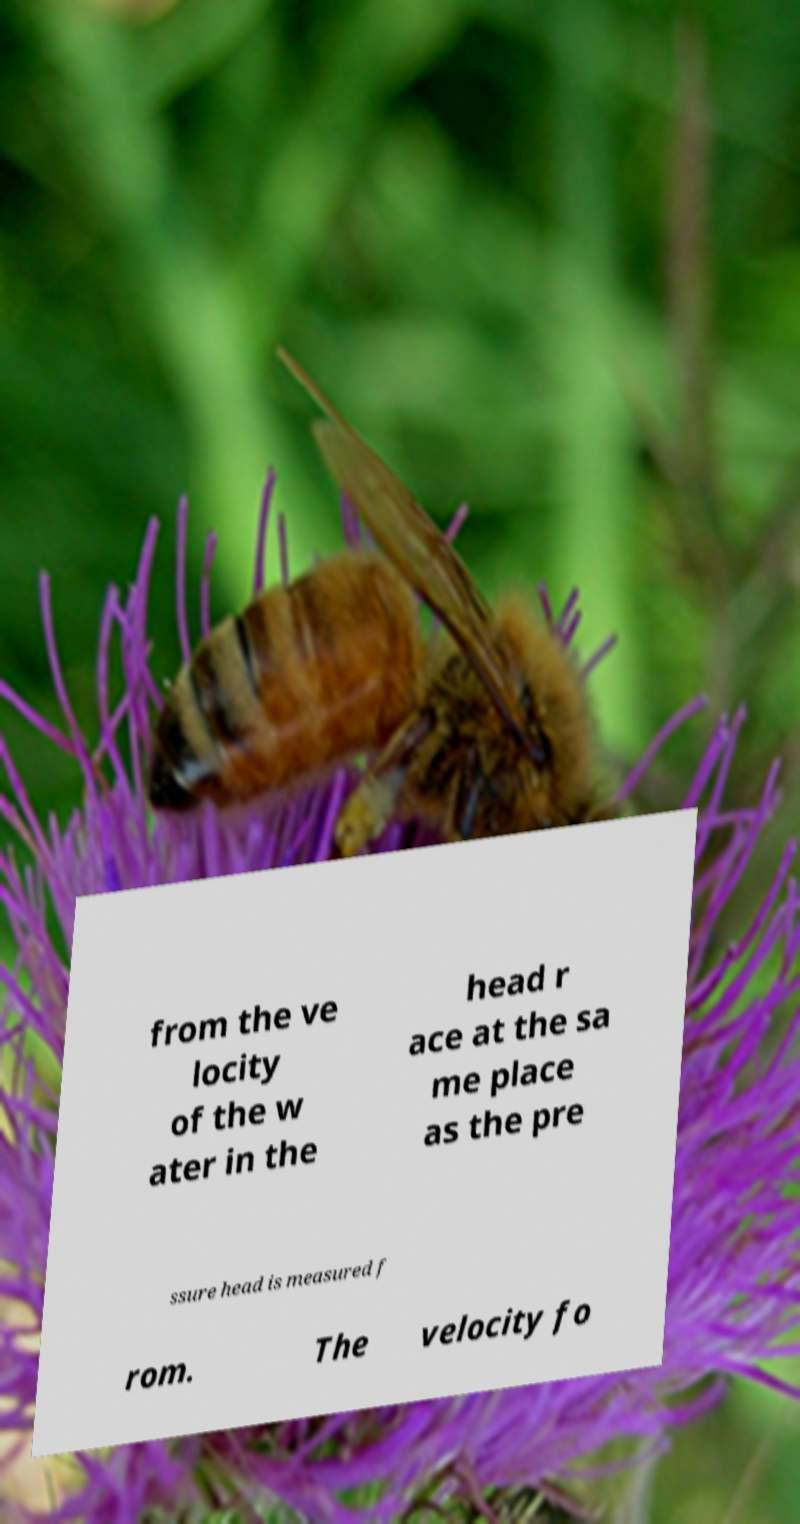There's text embedded in this image that I need extracted. Can you transcribe it verbatim? from the ve locity of the w ater in the head r ace at the sa me place as the pre ssure head is measured f rom. The velocity fo 